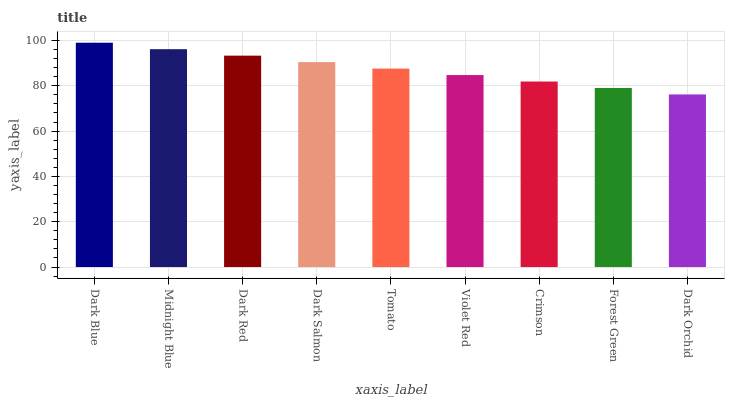Is Dark Orchid the minimum?
Answer yes or no. Yes. Is Dark Blue the maximum?
Answer yes or no. Yes. Is Midnight Blue the minimum?
Answer yes or no. No. Is Midnight Blue the maximum?
Answer yes or no. No. Is Dark Blue greater than Midnight Blue?
Answer yes or no. Yes. Is Midnight Blue less than Dark Blue?
Answer yes or no. Yes. Is Midnight Blue greater than Dark Blue?
Answer yes or no. No. Is Dark Blue less than Midnight Blue?
Answer yes or no. No. Is Tomato the high median?
Answer yes or no. Yes. Is Tomato the low median?
Answer yes or no. Yes. Is Crimson the high median?
Answer yes or no. No. Is Crimson the low median?
Answer yes or no. No. 